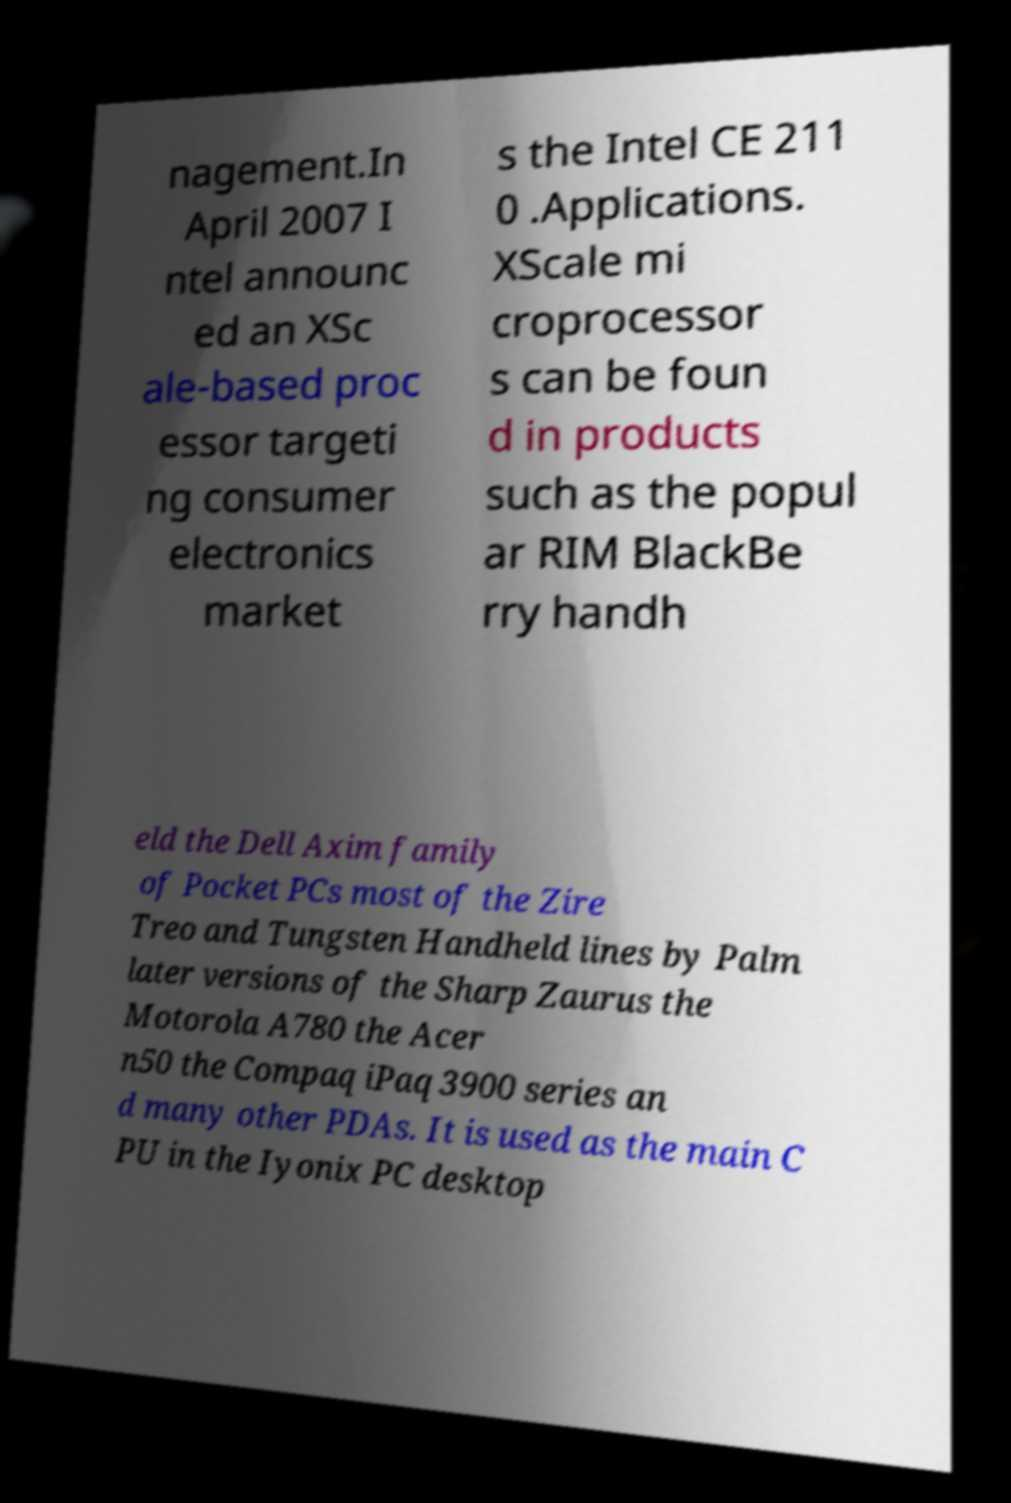For documentation purposes, I need the text within this image transcribed. Could you provide that? nagement.In April 2007 I ntel announc ed an XSc ale-based proc essor targeti ng consumer electronics market s the Intel CE 211 0 .Applications. XScale mi croprocessor s can be foun d in products such as the popul ar RIM BlackBe rry handh eld the Dell Axim family of Pocket PCs most of the Zire Treo and Tungsten Handheld lines by Palm later versions of the Sharp Zaurus the Motorola A780 the Acer n50 the Compaq iPaq 3900 series an d many other PDAs. It is used as the main C PU in the Iyonix PC desktop 